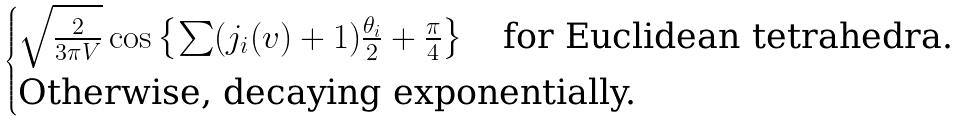Convert formula to latex. <formula><loc_0><loc_0><loc_500><loc_500>\begin{cases} \sqrt { \frac { 2 } { 3 \pi V } } \cos \left \{ \sum ( j _ { i } ( v ) + 1 ) \frac { \theta _ { i } } { 2 } + \frac { \pi } { 4 } \right \} \quad \text {for Euclidean tetrahedra.} \\ \text {Otherwise, decaying exponentially.} \end{cases}</formula> 